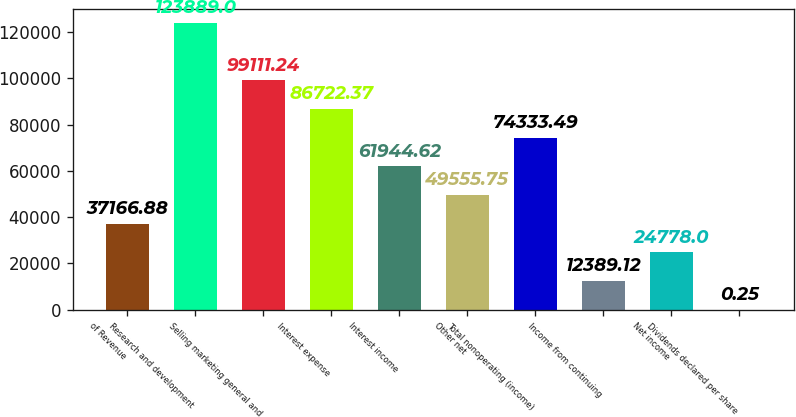Convert chart to OTSL. <chart><loc_0><loc_0><loc_500><loc_500><bar_chart><fcel>of Revenue<fcel>Research and development<fcel>Selling marketing general and<fcel>Interest expense<fcel>Interest income<fcel>Other net<fcel>Total nonoperating (income)<fcel>Income from continuing<fcel>Net income<fcel>Dividends declared per share<nl><fcel>37166.9<fcel>123889<fcel>99111.2<fcel>86722.4<fcel>61944.6<fcel>49555.8<fcel>74333.5<fcel>12389.1<fcel>24778<fcel>0.25<nl></chart> 